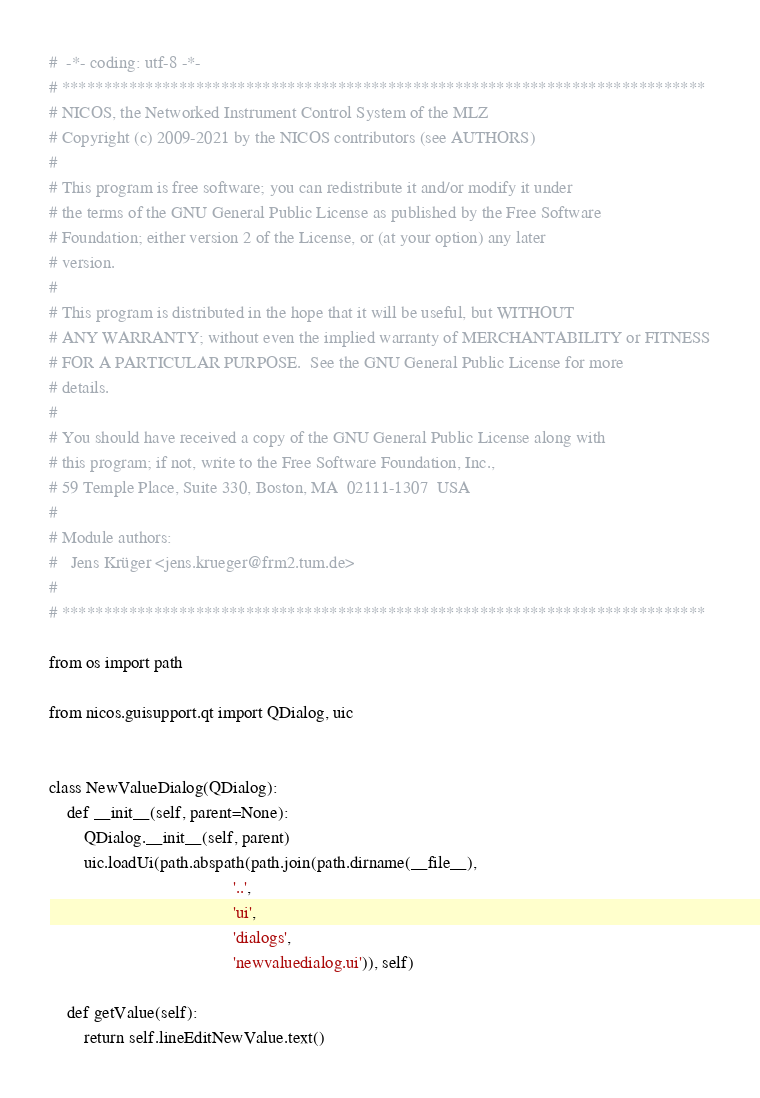Convert code to text. <code><loc_0><loc_0><loc_500><loc_500><_Python_>#  -*- coding: utf-8 -*-
# *****************************************************************************
# NICOS, the Networked Instrument Control System of the MLZ
# Copyright (c) 2009-2021 by the NICOS contributors (see AUTHORS)
#
# This program is free software; you can redistribute it and/or modify it under
# the terms of the GNU General Public License as published by the Free Software
# Foundation; either version 2 of the License, or (at your option) any later
# version.
#
# This program is distributed in the hope that it will be useful, but WITHOUT
# ANY WARRANTY; without even the implied warranty of MERCHANTABILITY or FITNESS
# FOR A PARTICULAR PURPOSE.  See the GNU General Public License for more
# details.
#
# You should have received a copy of the GNU General Public License along with
# this program; if not, write to the Free Software Foundation, Inc.,
# 59 Temple Place, Suite 330, Boston, MA  02111-1307  USA
#
# Module authors:
#   Jens Krüger <jens.krueger@frm2.tum.de>
#
# *****************************************************************************

from os import path

from nicos.guisupport.qt import QDialog, uic


class NewValueDialog(QDialog):
    def __init__(self, parent=None):
        QDialog.__init__(self, parent)
        uic.loadUi(path.abspath(path.join(path.dirname(__file__),
                                          '..',
                                          'ui',
                                          'dialogs',
                                          'newvaluedialog.ui')), self)

    def getValue(self):
        return self.lineEditNewValue.text()
</code> 